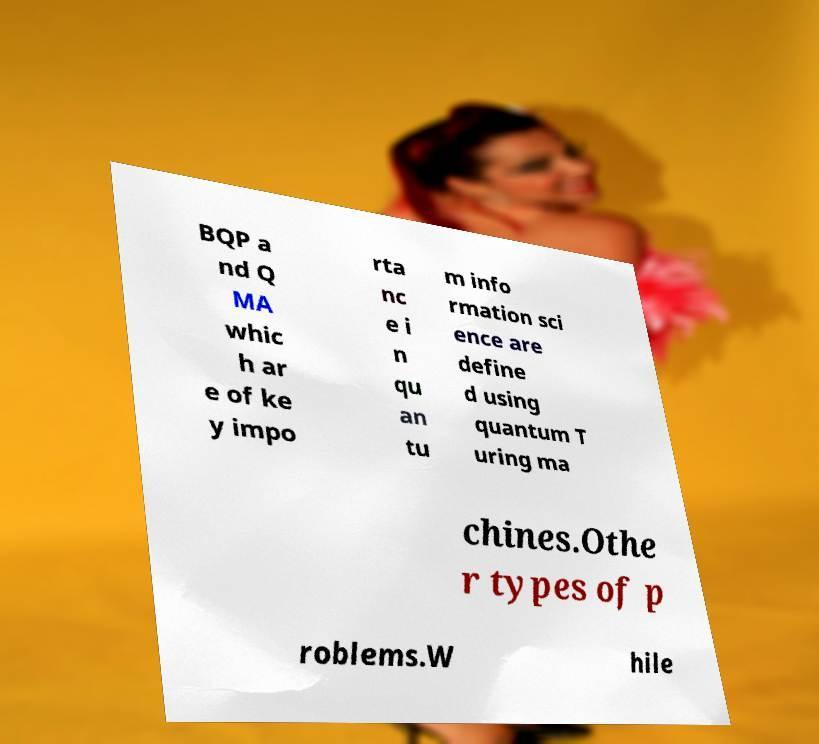For documentation purposes, I need the text within this image transcribed. Could you provide that? BQP a nd Q MA whic h ar e of ke y impo rta nc e i n qu an tu m info rmation sci ence are define d using quantum T uring ma chines.Othe r types of p roblems.W hile 